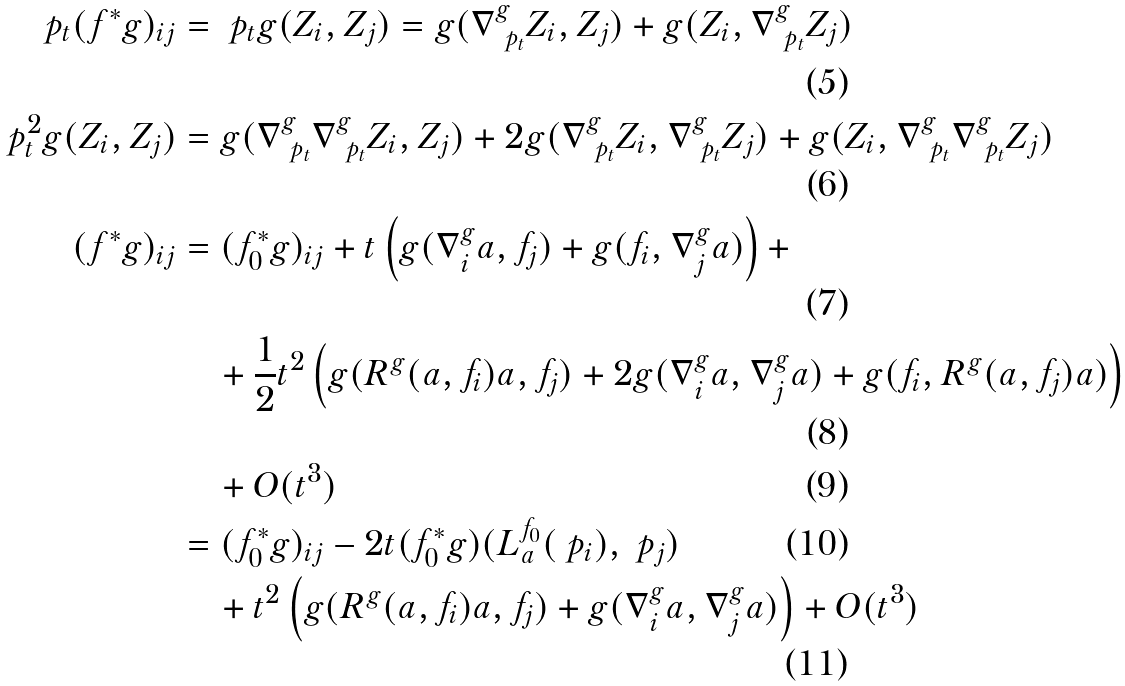Convert formula to latex. <formula><loc_0><loc_0><loc_500><loc_500>\ p _ { t } ( f ^ { * } g ) _ { i j } & = \ p _ { t } g ( Z _ { i } , Z _ { j } ) = g ( \nabla ^ { g } _ { \ p _ { t } } Z _ { i } , Z _ { j } ) + g ( Z _ { i } , \nabla ^ { g } _ { \ p _ { t } } Z _ { j } ) \\ \ p _ { t } ^ { 2 } g ( Z _ { i } , Z _ { j } ) & = g ( \nabla ^ { g } _ { \ p _ { t } } \nabla ^ { g } _ { \ p _ { t } } Z _ { i } , Z _ { j } ) + 2 g ( \nabla ^ { g } _ { \ p _ { t } } Z _ { i } , \nabla ^ { g } _ { \ p _ { t } } Z _ { j } ) + g ( Z _ { i } , \nabla ^ { g } _ { \ p _ { t } } \nabla ^ { g } _ { \ p _ { t } } Z _ { j } ) \\ ( f ^ { * } g ) _ { i j } & = ( f _ { 0 } ^ { * } g ) _ { i j } + t \left ( g ( \nabla ^ { g } _ { i } a , f _ { j } ) + g ( f _ { i } , \nabla ^ { g } _ { j } a ) \right ) + \\ & \quad + \frac { 1 } { 2 } { t ^ { 2 } } \left ( g ( R ^ { g } ( a , f _ { i } ) a , f _ { j } ) + 2 g ( \nabla ^ { g } _ { i } a , \nabla ^ { g } _ { j } a ) + g ( f _ { i } , R ^ { g } ( a , f _ { j } ) a ) \right ) \\ & \quad + O ( t ^ { 3 } ) \\ & = ( f _ { 0 } ^ { * } g ) _ { i j } - 2 t ( f _ { 0 } ^ { * } g ) ( L ^ { f _ { 0 } } _ { a } ( \ p _ { i } ) , \ p _ { j } ) \\ & \quad + t ^ { 2 } \left ( g ( R ^ { g } ( a , f _ { i } ) a , f _ { j } ) + g ( \nabla ^ { g } _ { i } a , \nabla ^ { g } _ { j } a ) \right ) + O ( t ^ { 3 } )</formula> 